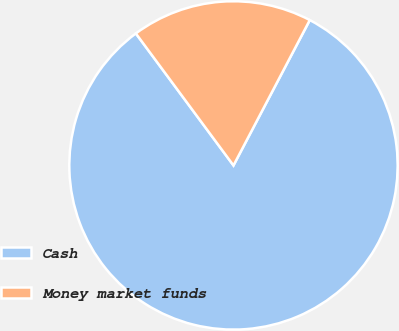Convert chart to OTSL. <chart><loc_0><loc_0><loc_500><loc_500><pie_chart><fcel>Cash<fcel>Money market funds<nl><fcel>82.17%<fcel>17.83%<nl></chart> 